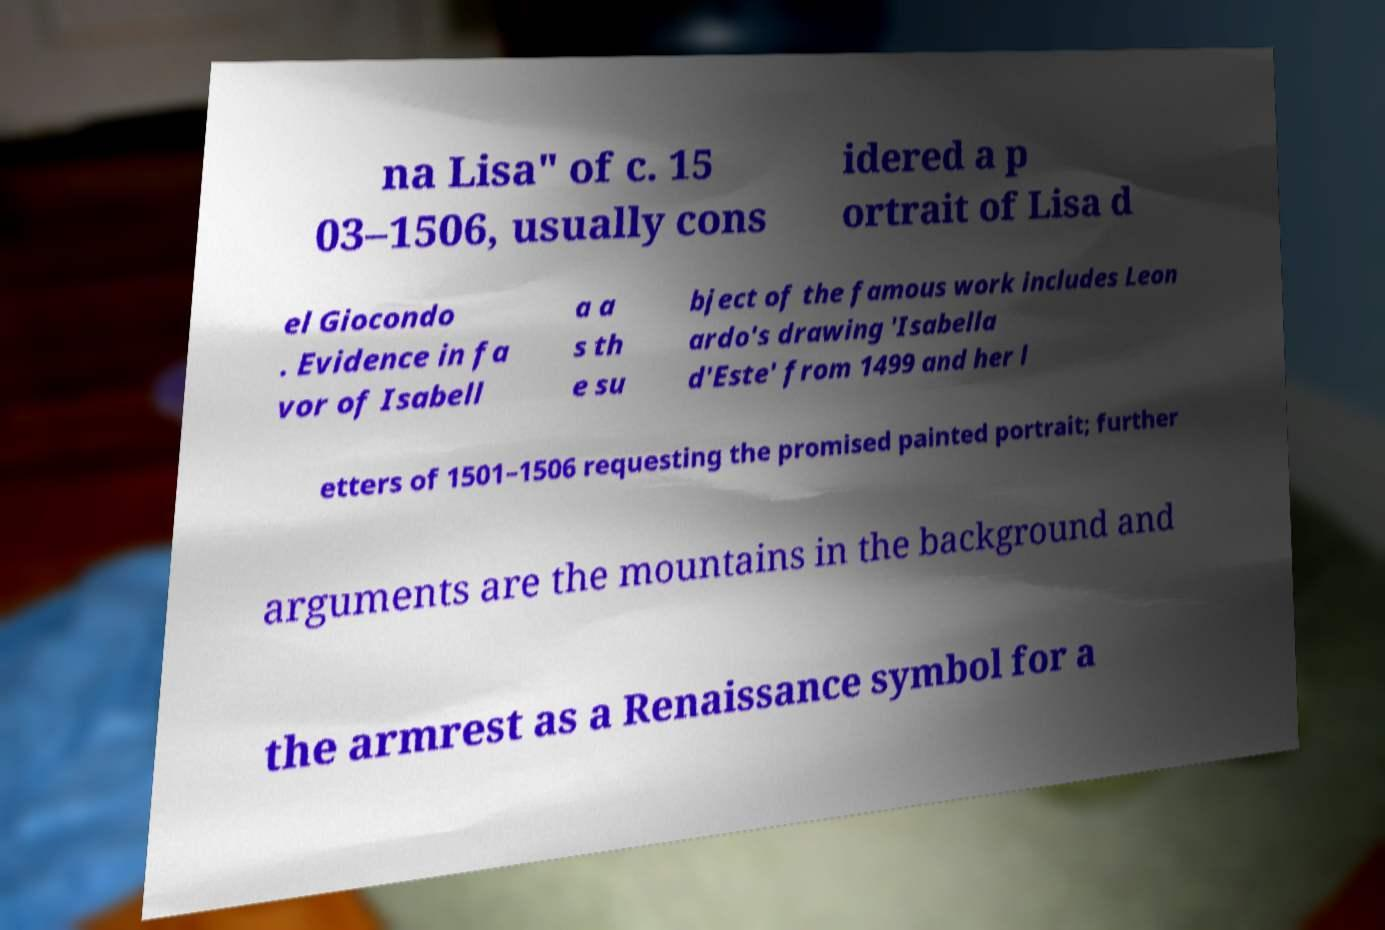Please read and relay the text visible in this image. What does it say? na Lisa" of c. 15 03–1506, usually cons idered a p ortrait of Lisa d el Giocondo . Evidence in fa vor of Isabell a a s th e su bject of the famous work includes Leon ardo's drawing 'Isabella d'Este' from 1499 and her l etters of 1501–1506 requesting the promised painted portrait; further arguments are the mountains in the background and the armrest as a Renaissance symbol for a 